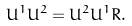<formula> <loc_0><loc_0><loc_500><loc_500>U ^ { 1 } U ^ { 2 } = U ^ { 2 } U ^ { 1 } R .</formula> 